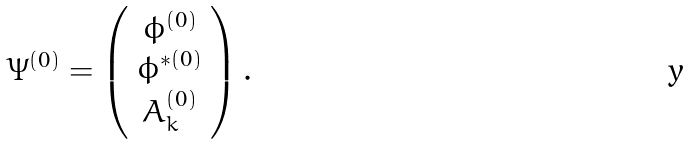<formula> <loc_0><loc_0><loc_500><loc_500>\Psi ^ { ( 0 ) } = \left ( \begin{array} { c } \phi ^ { ( 0 ) } \\ \phi ^ { \ast ( 0 ) } \\ A _ { k } ^ { ( 0 ) } \end{array} \right ) .</formula> 